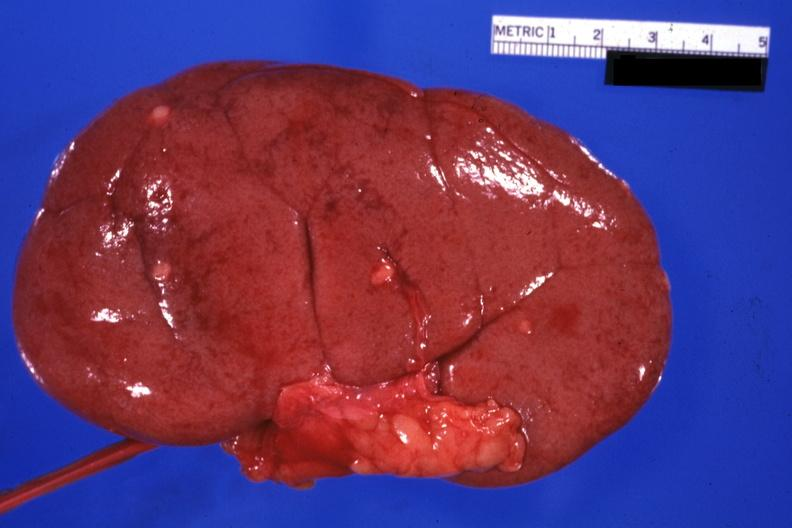what is present?
Answer the question using a single word or phrase. Kidney 